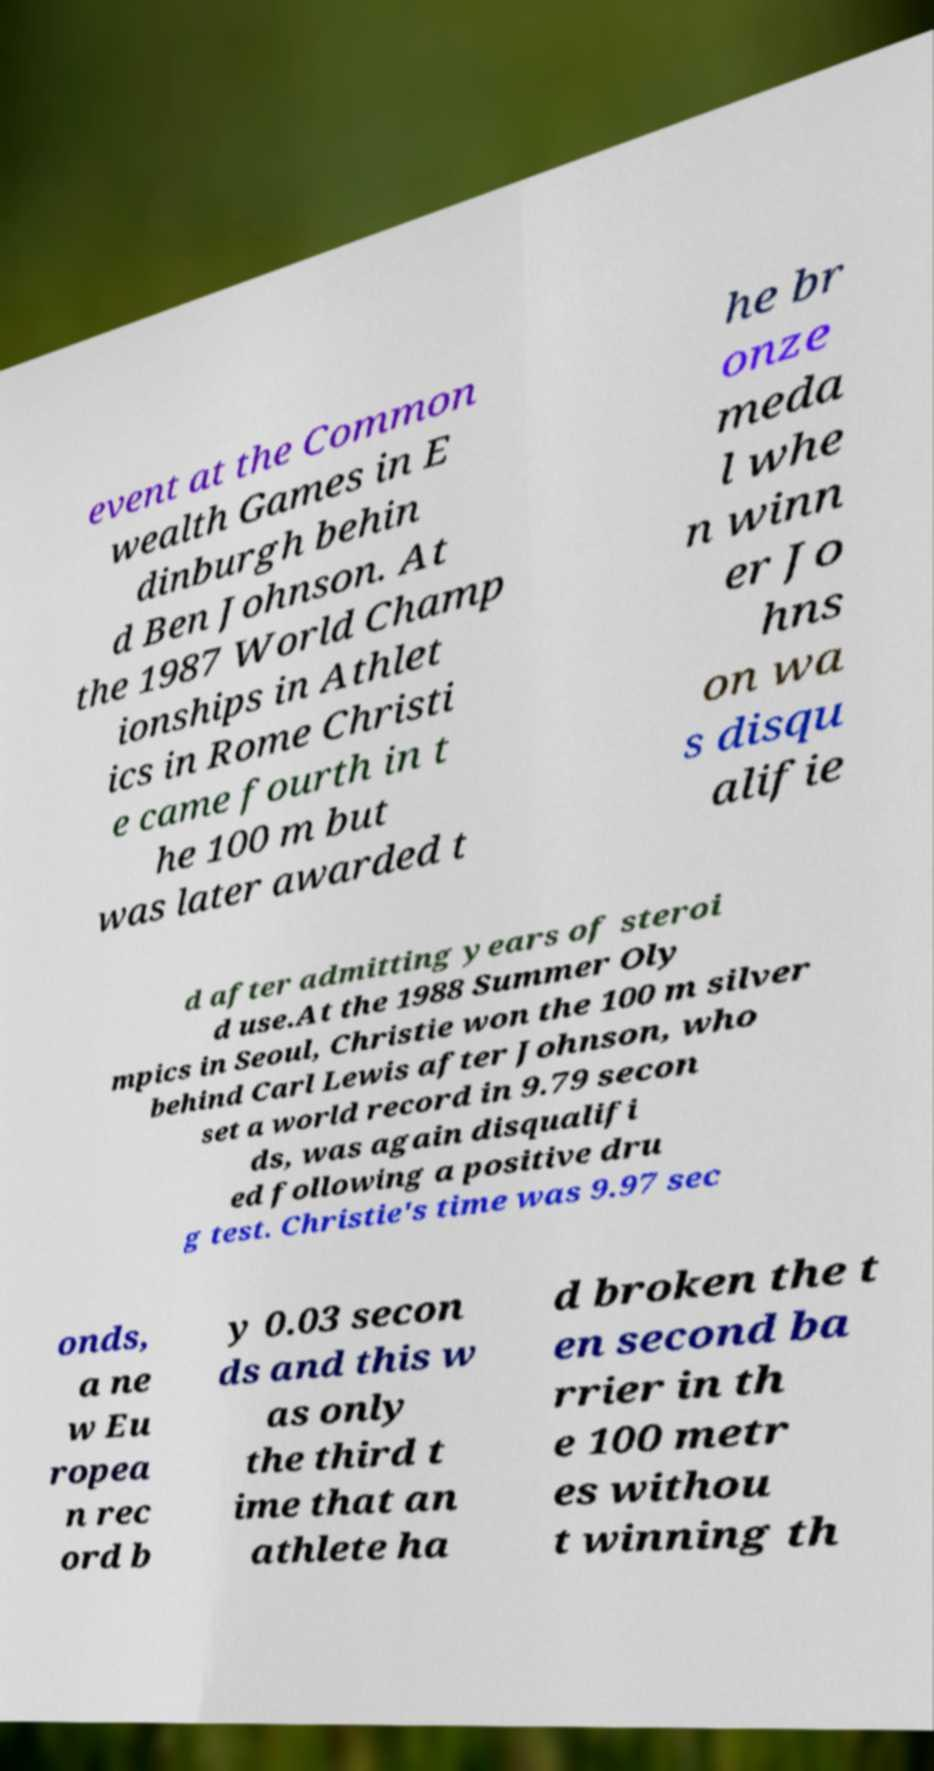I need the written content from this picture converted into text. Can you do that? event at the Common wealth Games in E dinburgh behin d Ben Johnson. At the 1987 World Champ ionships in Athlet ics in Rome Christi e came fourth in t he 100 m but was later awarded t he br onze meda l whe n winn er Jo hns on wa s disqu alifie d after admitting years of steroi d use.At the 1988 Summer Oly mpics in Seoul, Christie won the 100 m silver behind Carl Lewis after Johnson, who set a world record in 9.79 secon ds, was again disqualifi ed following a positive dru g test. Christie's time was 9.97 sec onds, a ne w Eu ropea n rec ord b y 0.03 secon ds and this w as only the third t ime that an athlete ha d broken the t en second ba rrier in th e 100 metr es withou t winning th 